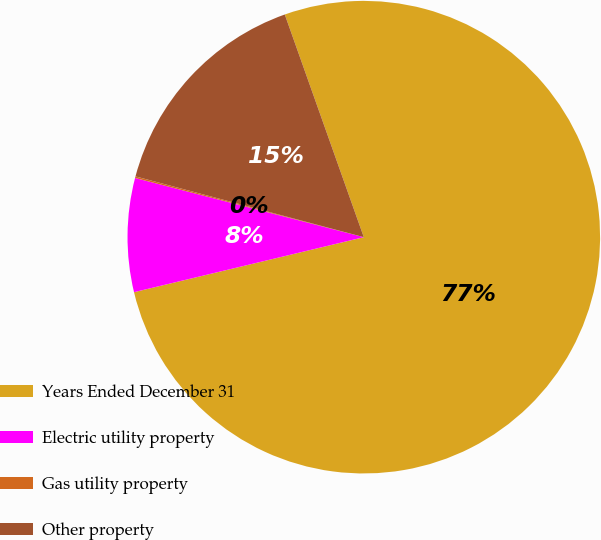Convert chart. <chart><loc_0><loc_0><loc_500><loc_500><pie_chart><fcel>Years Ended December 31<fcel>Electric utility property<fcel>Gas utility property<fcel>Other property<nl><fcel>76.69%<fcel>7.77%<fcel>0.11%<fcel>15.43%<nl></chart> 